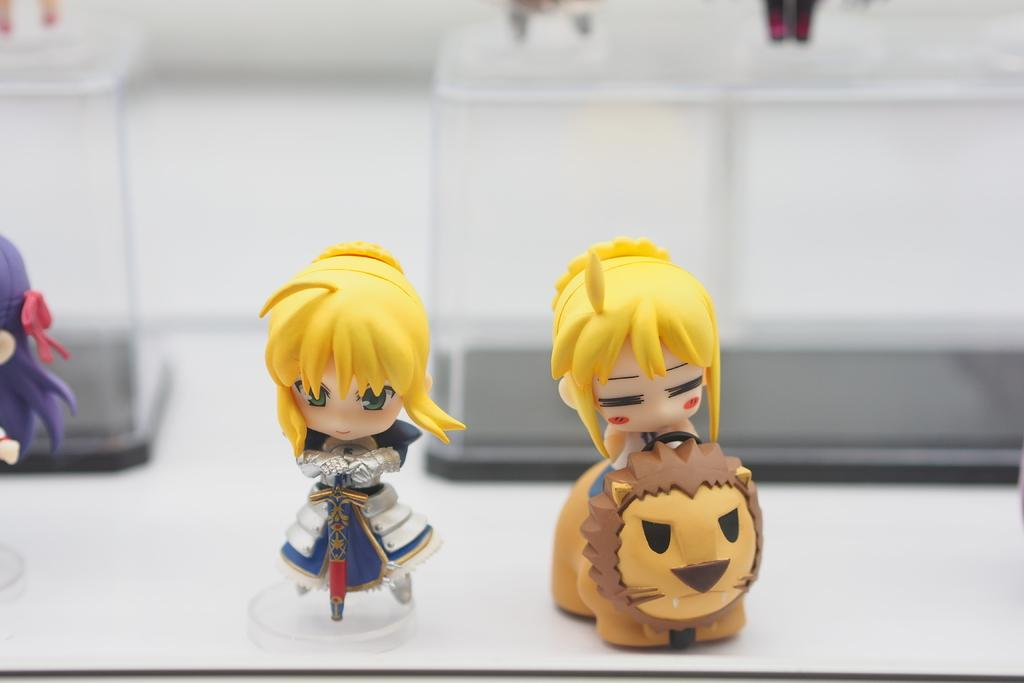How many toys are visible in the image? There are 4 toys in the image. What is the color of the surface on which the toys are placed? The toys are on a white color surface. Can you describe the background of the image? The background of the image is slightly blurry. What type of credit card is being used to purchase a ticket at the airport in the image? There is no credit card or airport present in the image; it only features 4 toys on a white surface. 